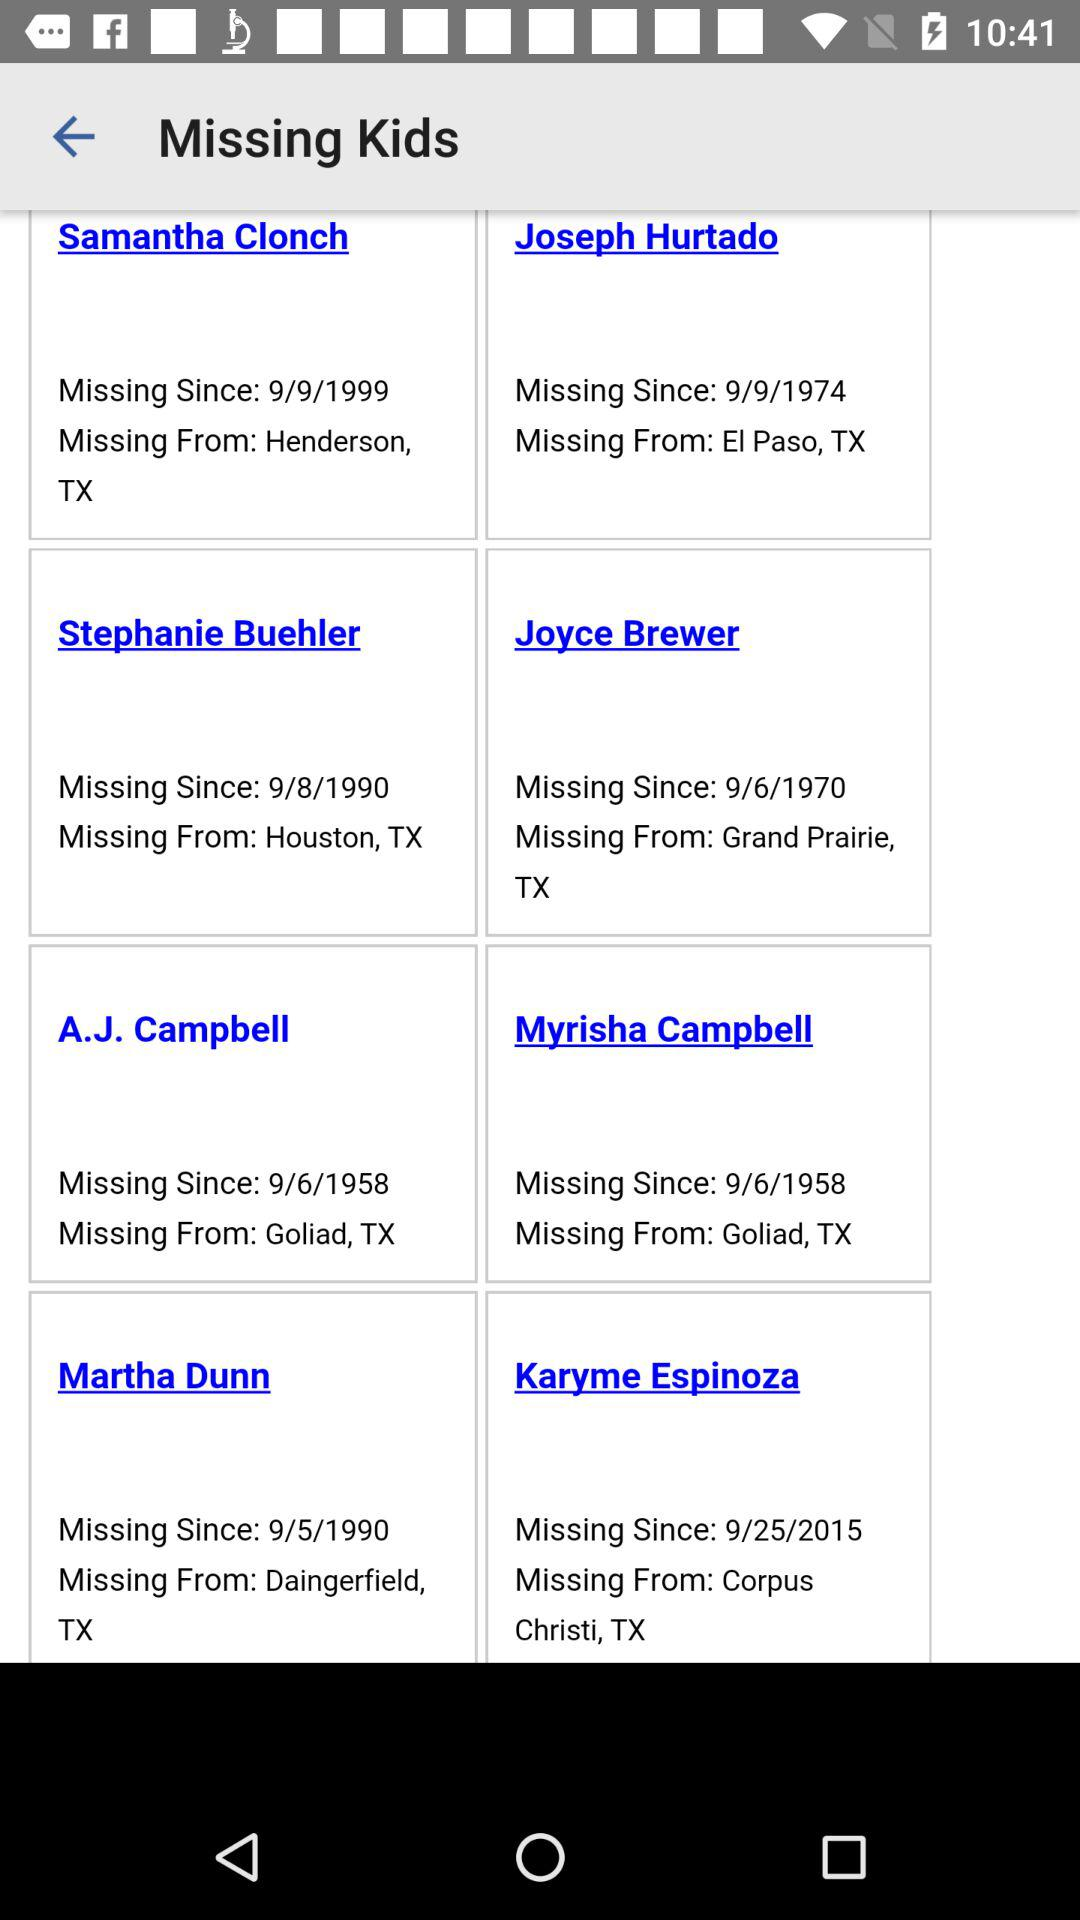What is the Joyce Brewer's missing date? Joyce Brewer's missing date is 9/6/1970. 